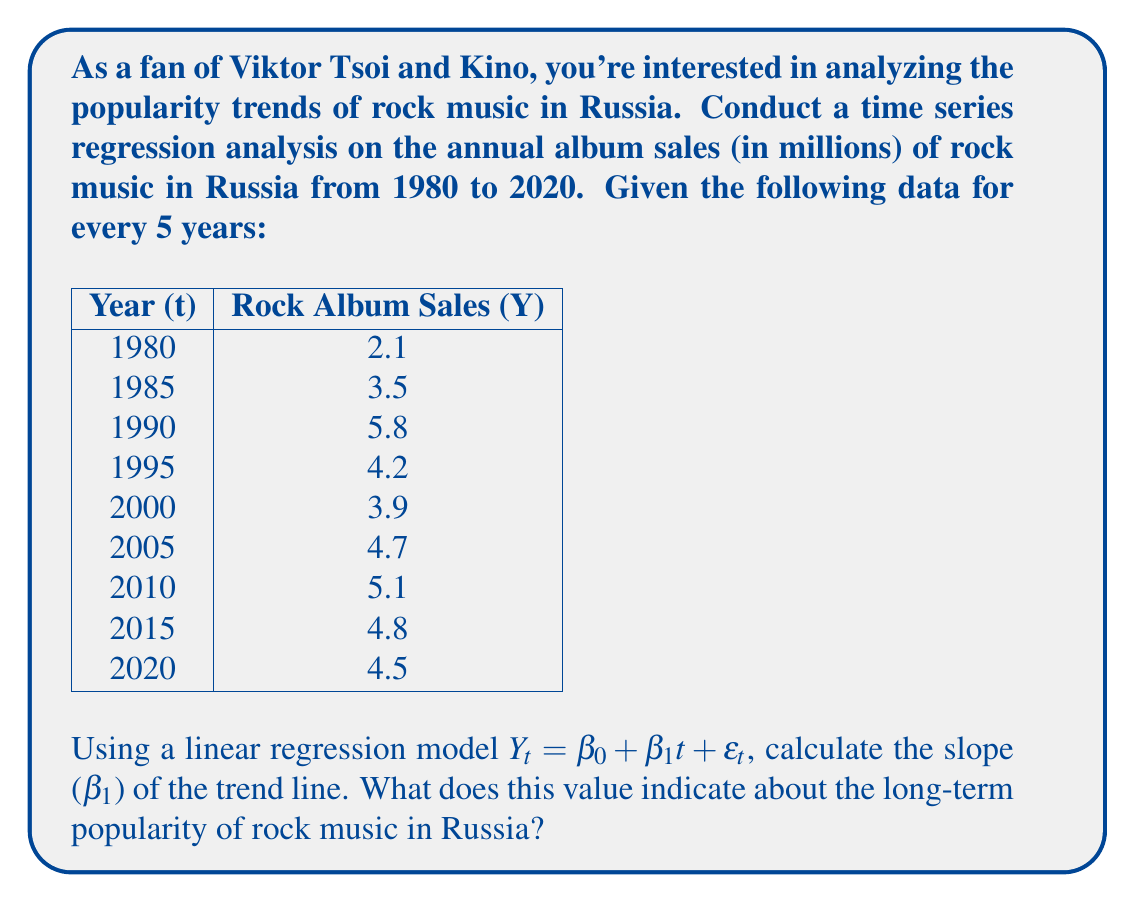Teach me how to tackle this problem. To solve this problem, we'll use the linear regression model for time series data:

$Y_t = \beta_0 + \beta_1t + \epsilon_t$

Where:
$Y_t$ is the rock album sales in millions
$t$ is the time variable (we'll use years since 1980)
$\beta_0$ is the y-intercept
$\beta_1$ is the slope (our main interest)
$\epsilon_t$ is the error term

To calculate $\beta_1$, we'll use the formula:

$$\beta_1 = \frac{n\sum_{i=1}^n t_iY_i - \sum_{i=1}^n t_i \sum_{i=1}^n Y_i}{n\sum_{i=1}^n t_i^2 - (\sum_{i=1}^n t_i)^2}$$

First, let's prepare our data:

i | t_i | Y_i | t_i * Y_i | t_i^2
1 | 0 | 2.1 | 0 | 0
2 | 5 | 3.5 | 17.5 | 25
3 | 10 | 5.8 | 58 | 100
4 | 15 | 4.2 | 63 | 225
5 | 20 | 3.9 | 78 | 400
6 | 25 | 4.7 | 117.5 | 625
7 | 30 | 5.1 | 153 | 900
8 | 35 | 4.8 | 168 | 1225
9 | 40 | 4.5 | 180 | 1600

Now, let's calculate the sums:
$n = 9$
$\sum t_i = 180$
$\sum Y_i = 38.6$
$\sum (t_i * Y_i) = 835$
$\sum t_i^2 = 5100$

Plugging these values into our formula:

$$\beta_1 = \frac{9(835) - (180)(38.6)}{9(5100) - (180)^2}$$

$$\beta_1 = \frac{7515 - 6948}{45900 - 32400}$$

$$\beta_1 = \frac{567}{13500} = 0.042$$

The slope $\beta_1 = 0.042$ indicates that, on average, rock album sales in Russia increased by 0.042 million (or 42,000) units per year from 1980 to 2020.
Answer: $\beta_1 = 0.042$

This positive slope indicates a slight upward trend in the popularity of rock music in Russia from 1980 to 2020, with an average increase of 42,000 album sales per year. 